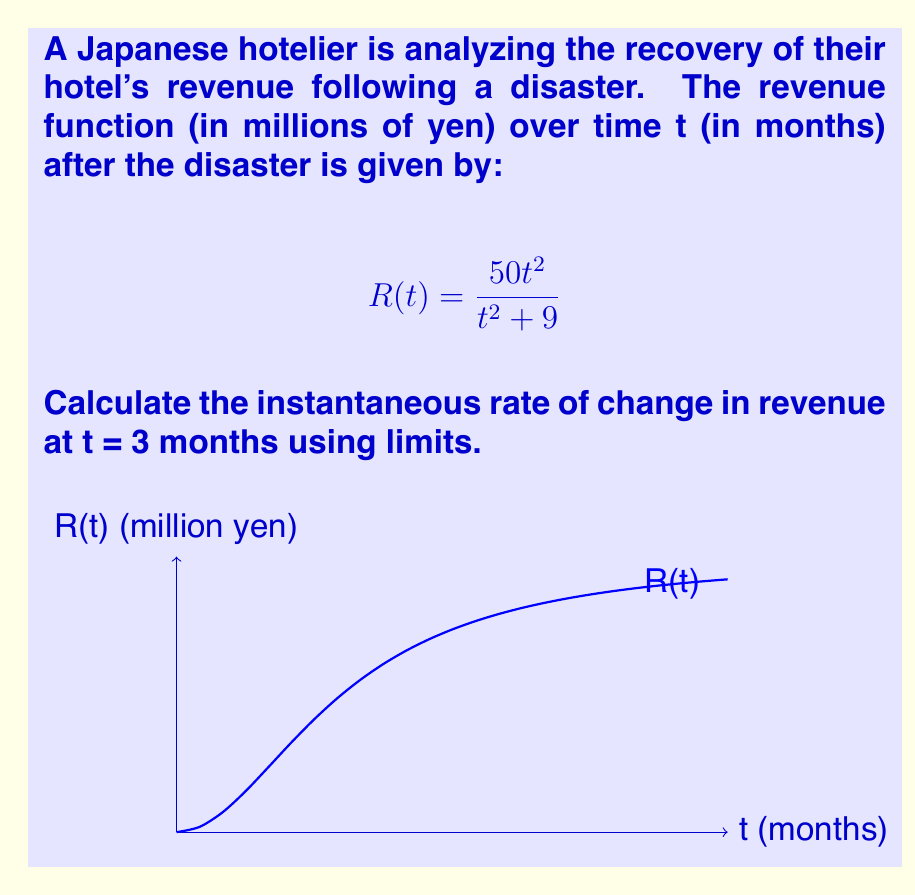Can you solve this math problem? To find the instantaneous rate of change at t = 3 months, we need to calculate the derivative of R(t) at t = 3 using the definition of the derivative:

$$R'(3) = \lim_{h \to 0} \frac{R(3+h) - R(3)}{h}$$

Step 1: Calculate R(3)
$$R(3) = \frac{50(3)^2}{3^2 + 9} = \frac{450}{18} = 25$$

Step 2: Calculate R(3+h)
$$R(3+h) = \frac{50(3+h)^2}{(3+h)^2 + 9}$$

Step 3: Set up the limit
$$\lim_{h \to 0} \frac{\frac{50(3+h)^2}{(3+h)^2 + 9} - 25}{h}$$

Step 4: Simplify the numerator
$$\lim_{h \to 0} \frac{\frac{50(9+6h+h^2)}{9+6h+h^2+9} - \frac{450}{18}}{h}$$
$$= \lim_{h \to 0} \frac{\frac{450+300h+50h^2}{18+6h+h^2} - \frac{450}{18}}{h}$$

Step 5: Find a common denominator and subtract
$$= \lim_{h \to 0} \frac{\frac{450(18+6h+h^2)+300h(18)+50h^2(18)-(450)(18+6h+h^2)}{18(18+6h+h^2)}}{h}$$

Step 6: Simplify the numerator
$$= \lim_{h \to 0} \frac{5400h+900h^2}{18h(18+6h+h^2)}$$

Step 7: Cancel h in numerator and denominator
$$= \lim_{h \to 0} \frac{5400+900h}{18(18+6h+h^2)}$$

Step 8: Evaluate the limit as h approaches 0
$$= \frac{5400}{18(18)} = \frac{300}{18} = \frac{50}{3}$$

Therefore, the instantaneous rate of change in revenue at t = 3 months is 50/3 million yen per month.
Answer: $\frac{50}{3}$ million yen per month 